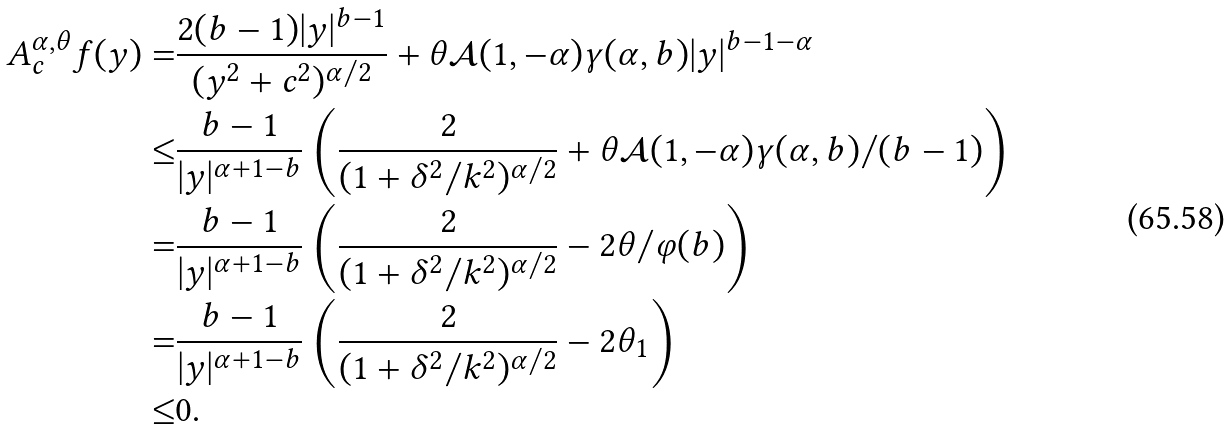Convert formula to latex. <formula><loc_0><loc_0><loc_500><loc_500>A _ { c } ^ { \alpha , \theta } f ( y ) = & \frac { 2 ( b - 1 ) | y | ^ { b - 1 } } { ( y ^ { 2 } + c ^ { 2 } ) ^ { \alpha / 2 } } + \theta \mathcal { A } ( 1 , - \alpha ) \gamma ( \alpha , b ) | y | ^ { b - 1 - \alpha } \\ \leq & \frac { b - 1 } { | y | ^ { \alpha + 1 - b } } \left ( \frac { 2 } { ( 1 + \delta ^ { 2 } / k ^ { 2 } ) ^ { \alpha / 2 } } + \theta \mathcal { A } ( 1 , - \alpha ) \gamma ( \alpha , b ) / ( b - 1 ) \right ) \\ = & \frac { b - 1 } { | y | ^ { \alpha + 1 - b } } \left ( \frac { 2 } { ( 1 + \delta ^ { 2 } / k ^ { 2 } ) ^ { \alpha / 2 } } - 2 \theta / \varphi ( b ) \right ) \\ = & \frac { b - 1 } { | y | ^ { \alpha + 1 - b } } \left ( \frac { 2 } { ( 1 + \delta ^ { 2 } / k ^ { 2 } ) ^ { \alpha / 2 } } - 2 \theta _ { 1 } \right ) \\ \leq & 0 .</formula> 